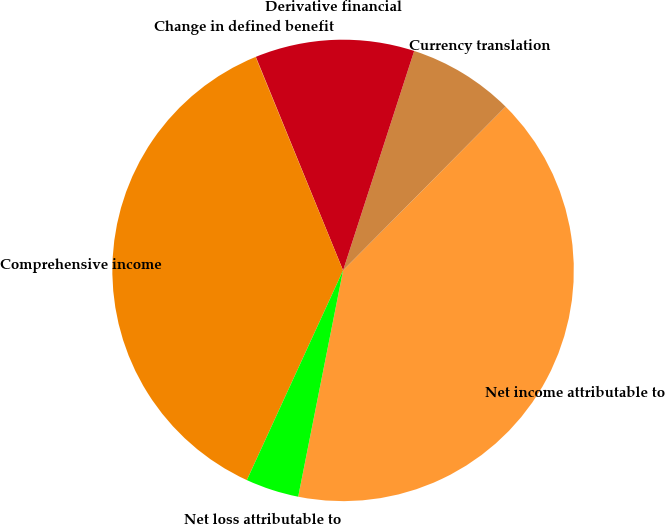Convert chart to OTSL. <chart><loc_0><loc_0><loc_500><loc_500><pie_chart><fcel>Net income attributable to<fcel>Currency translation<fcel>Derivative financial<fcel>Change in defined benefit<fcel>Comprehensive income<fcel>Net loss attributable to<nl><fcel>40.68%<fcel>7.45%<fcel>11.16%<fcel>0.02%<fcel>36.96%<fcel>3.73%<nl></chart> 